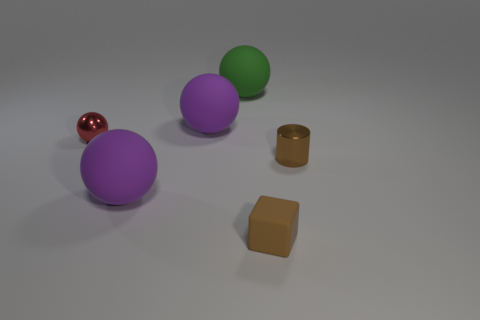Subtract all tiny balls. How many balls are left? 3 Add 3 large gray balls. How many objects exist? 9 Subtract all purple balls. How many balls are left? 2 Subtract all cylinders. How many objects are left? 5 Subtract all cyan blocks. How many purple spheres are left? 2 Subtract all red cylinders. Subtract all yellow blocks. How many cylinders are left? 1 Add 2 big brown cylinders. How many big brown cylinders exist? 2 Subtract 1 brown cylinders. How many objects are left? 5 Subtract all brown cubes. Subtract all tiny matte things. How many objects are left? 4 Add 4 spheres. How many spheres are left? 8 